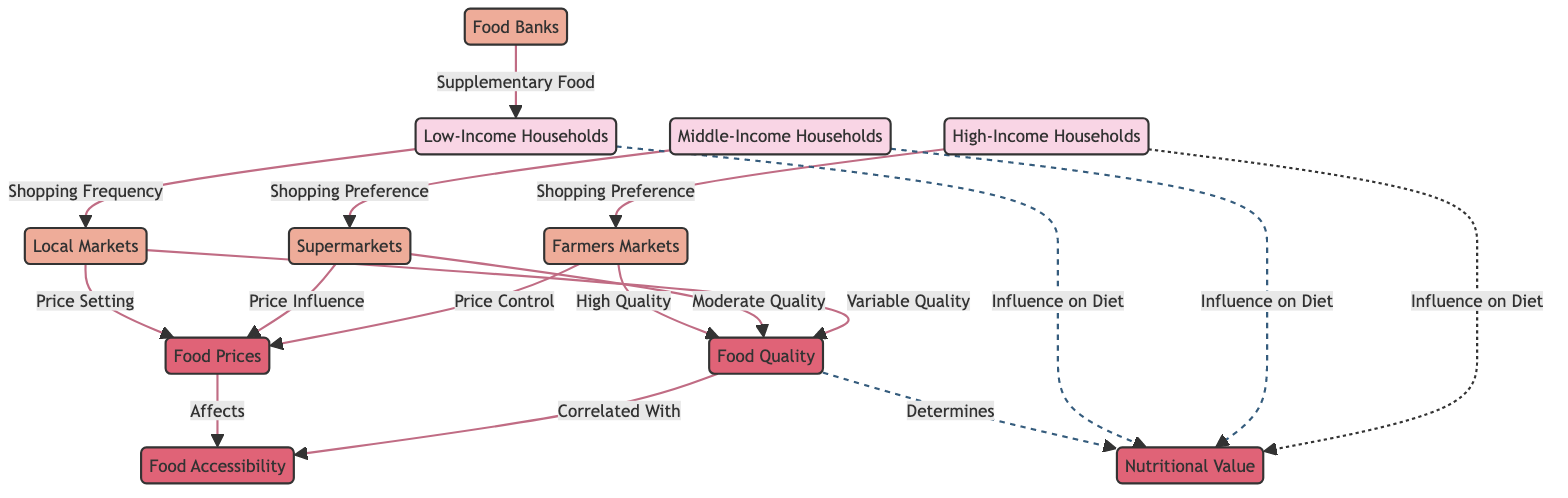What is the primary shopping frequency of low-income households? The diagram indicates that low-income households primarily shop at local markets, so their shopping frequency is associated with these markets.
Answer: Local Markets Which socioeconomic class prefers supermarkets for shopping? According to the diagram, middle-income households are linked to supermarkets as their preferred shopping option.
Answer: Middle-Income Households How many types of markets are represented in the diagram? The diagram includes four types of markets: local markets, supermarkets, farmers markets, and food banks. Thus, the total count is simply the number of nodes labeled as markets.
Answer: Four How does food quality impact nutritional value? The diagram shows a direct relationship where food quality determines nutritional value, implying that better quality foods contribute to higher nutritional value.
Answer: Determines What supplementary food source is indicated for low-income households? The diagram explicitly illustrates that food banks provide supplementary food to low-income households, indicating an additional resource for these households.
Answer: Food Banks What is the relationship between food prices and food accessibility? The diagram indicates that food prices affect food accessibility, highlighting that higher prices can limit access to food resources for various socioeconomic classes.
Answer: Affects Which market type provides high-quality food? The diagram states that farmers markets are associated with high-quality food, implying they offer better quality compared to other market types.
Answer: Farmers Markets Which socioeconomic class influences their diet the least? The dashed connections imply that all socioeconomic classes have an influence on diet; however, since low-income households are linked with food banks and local markets, their influence may be complicated by the resource constraints, but it's not specifically weaker than others in the diagram.
Answer: Non-Specific Which factor is correlated with food accessibility? The diagram shows a direct correlation between food quality and food accessibility, highlighting that food quality positively influences access to food resources.
Answer: Correlated With 